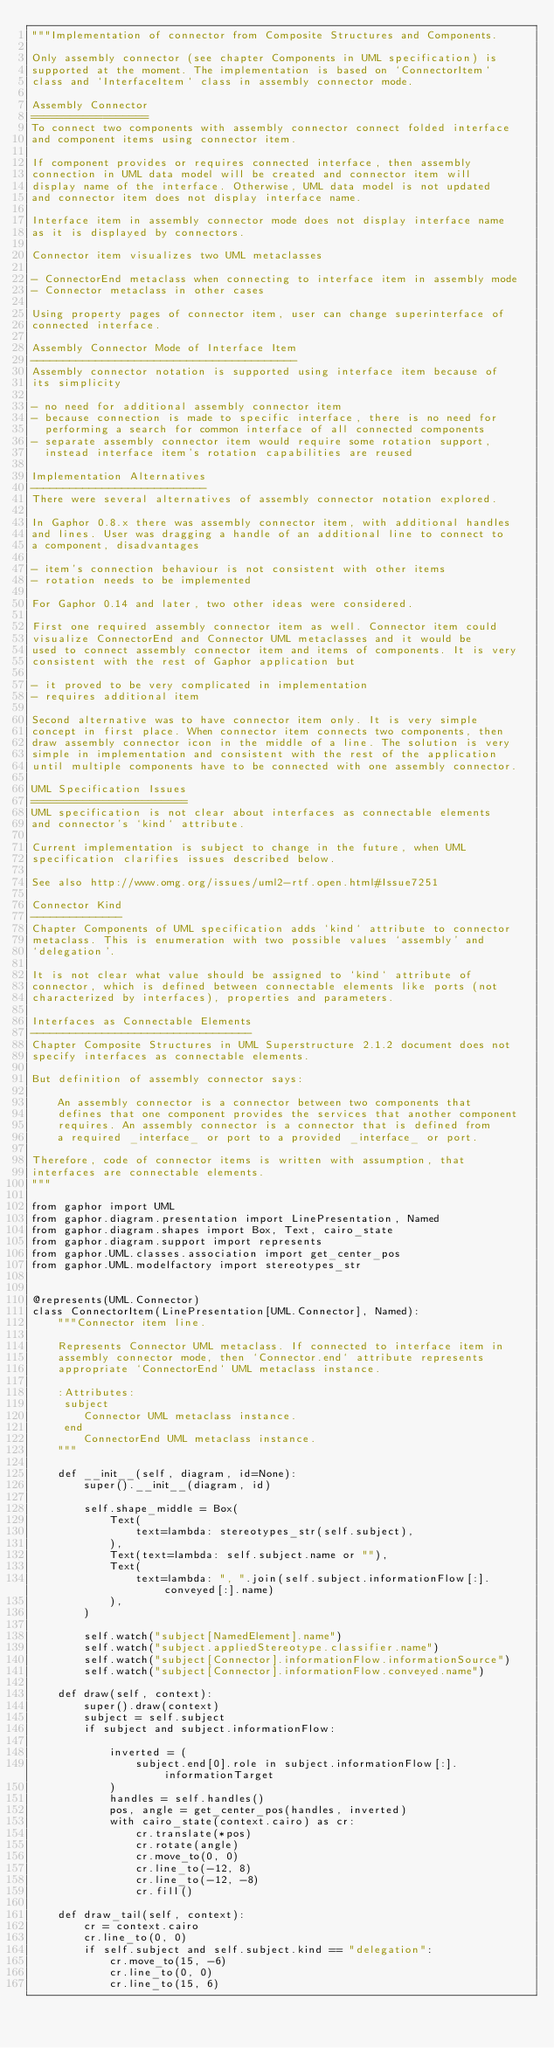<code> <loc_0><loc_0><loc_500><loc_500><_Python_>"""Implementation of connector from Composite Structures and Components.

Only assembly connector (see chapter Components in UML specification) is
supported at the moment. The implementation is based on `ConnectorItem`
class and `InterfaceItem` class in assembly connector mode.

Assembly Connector
==================
To connect two components with assembly connector connect folded interface
and component items using connector item.

If component provides or requires connected interface, then assembly
connection in UML data model will be created and connector item will
display name of the interface. Otherwise, UML data model is not updated
and connector item does not display interface name.

Interface item in assembly connector mode does not display interface name
as it is displayed by connectors.

Connector item visualizes two UML metaclasses

- ConnectorEnd metaclass when connecting to interface item in assembly mode
- Connector metaclass in other cases

Using property pages of connector item, user can change superinterface of
connected interface.

Assembly Connector Mode of Interface Item
-----------------------------------------
Assembly connector notation is supported using interface item because of
its simplicity

- no need for additional assembly connector item
- because connection is made to specific interface, there is no need for
  performing a search for common interface of all connected components
- separate assembly connector item would require some rotation support,
  instead interface item's rotation capabilities are reused

Implementation Alternatives
---------------------------
There were several alternatives of assembly connector notation explored.

In Gaphor 0.8.x there was assembly connector item, with additional handles
and lines. User was dragging a handle of an additional line to connect to
a component, disadvantages

- item's connection behaviour is not consistent with other items
- rotation needs to be implemented

For Gaphor 0.14 and later, two other ideas were considered.

First one required assembly connector item as well. Connector item could
visualize ConnectorEnd and Connector UML metaclasses and it would be
used to connect assembly connector item and items of components. It is very
consistent with the rest of Gaphor application but

- it proved to be very complicated in implementation
- requires additional item

Second alternative was to have connector item only. It is very simple
concept in first place. When connector item connects two components, then
draw assembly connector icon in the middle of a line. The solution is very
simple in implementation and consistent with the rest of the application
until multiple components have to be connected with one assembly connector.

UML Specification Issues
========================
UML specification is not clear about interfaces as connectable elements
and connector's `kind` attribute.

Current implementation is subject to change in the future, when UML
specification clarifies issues described below.

See also http://www.omg.org/issues/uml2-rtf.open.html#Issue7251

Connector Kind
--------------
Chapter Components of UML specification adds `kind` attribute to connector
metaclass. This is enumeration with two possible values `assembly' and
`delegation'.

It is not clear what value should be assigned to `kind` attribute of
connector, which is defined between connectable elements like ports (not
characterized by interfaces), properties and parameters.

Interfaces as Connectable Elements
----------------------------------
Chapter Composite Structures in UML Superstructure 2.1.2 document does not
specify interfaces as connectable elements.

But definition of assembly connector says:

    An assembly connector is a connector between two components that
    defines that one component provides the services that another component
    requires. An assembly connector is a connector that is defined from
    a required _interface_ or port to a provided _interface_ or port.

Therefore, code of connector items is written with assumption, that
interfaces are connectable elements.
"""

from gaphor import UML
from gaphor.diagram.presentation import LinePresentation, Named
from gaphor.diagram.shapes import Box, Text, cairo_state
from gaphor.diagram.support import represents
from gaphor.UML.classes.association import get_center_pos
from gaphor.UML.modelfactory import stereotypes_str


@represents(UML.Connector)
class ConnectorItem(LinePresentation[UML.Connector], Named):
    """Connector item line.

    Represents Connector UML metaclass. If connected to interface item in
    assembly connector mode, then `Connector.end` attribute represents
    appropriate `ConnectorEnd` UML metaclass instance.

    :Attributes:
     subject
        Connector UML metaclass instance.
     end
        ConnectorEnd UML metaclass instance.
    """

    def __init__(self, diagram, id=None):
        super().__init__(diagram, id)

        self.shape_middle = Box(
            Text(
                text=lambda: stereotypes_str(self.subject),
            ),
            Text(text=lambda: self.subject.name or ""),
            Text(
                text=lambda: ", ".join(self.subject.informationFlow[:].conveyed[:].name)
            ),
        )

        self.watch("subject[NamedElement].name")
        self.watch("subject.appliedStereotype.classifier.name")
        self.watch("subject[Connector].informationFlow.informationSource")
        self.watch("subject[Connector].informationFlow.conveyed.name")

    def draw(self, context):
        super().draw(context)
        subject = self.subject
        if subject and subject.informationFlow:

            inverted = (
                subject.end[0].role in subject.informationFlow[:].informationTarget
            )
            handles = self.handles()
            pos, angle = get_center_pos(handles, inverted)
            with cairo_state(context.cairo) as cr:
                cr.translate(*pos)
                cr.rotate(angle)
                cr.move_to(0, 0)
                cr.line_to(-12, 8)
                cr.line_to(-12, -8)
                cr.fill()

    def draw_tail(self, context):
        cr = context.cairo
        cr.line_to(0, 0)
        if self.subject and self.subject.kind == "delegation":
            cr.move_to(15, -6)
            cr.line_to(0, 0)
            cr.line_to(15, 6)
</code> 